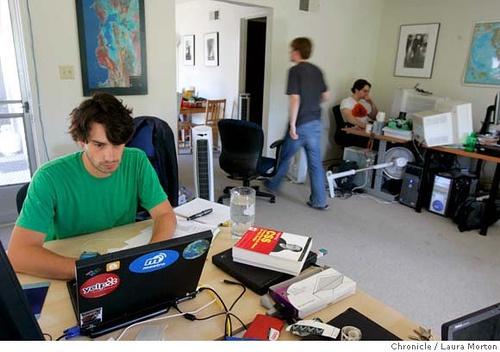Describe the objects in this image and their specific colors. I can see people in white, green, darkgreen, salmon, and black tones, laptop in white, black, gray, blue, and brown tones, people in white, black, navy, gray, and darkblue tones, chair in white, black, gray, and darkblue tones, and book in white, lightgray, darkgray, and black tones in this image. 